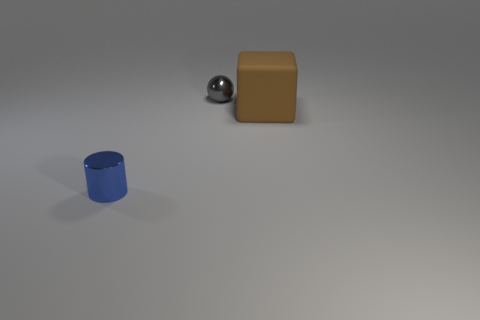Is there anything else that has the same material as the large cube?
Give a very brief answer. No. Is there anything else that has the same color as the tiny sphere?
Your response must be concise. No. There is a big brown thing behind the small metal cylinder; what material is it?
Provide a short and direct response. Rubber. Do the cube and the blue shiny object have the same size?
Provide a short and direct response. No. What number of other things are the same size as the blue metal cylinder?
Provide a succinct answer. 1. Do the big cube and the shiny sphere have the same color?
Your answer should be compact. No. What is the shape of the object that is in front of the big thing right of the tiny metallic thing that is behind the brown thing?
Offer a terse response. Cylinder. How many objects are either things that are right of the small gray metal sphere or small metallic things to the left of the small gray shiny ball?
Keep it short and to the point. 2. There is a metallic object that is behind the small thing that is in front of the gray sphere; what is its size?
Your answer should be very brief. Small. What is the color of the sphere that is the same size as the blue object?
Offer a very short reply. Gray. 